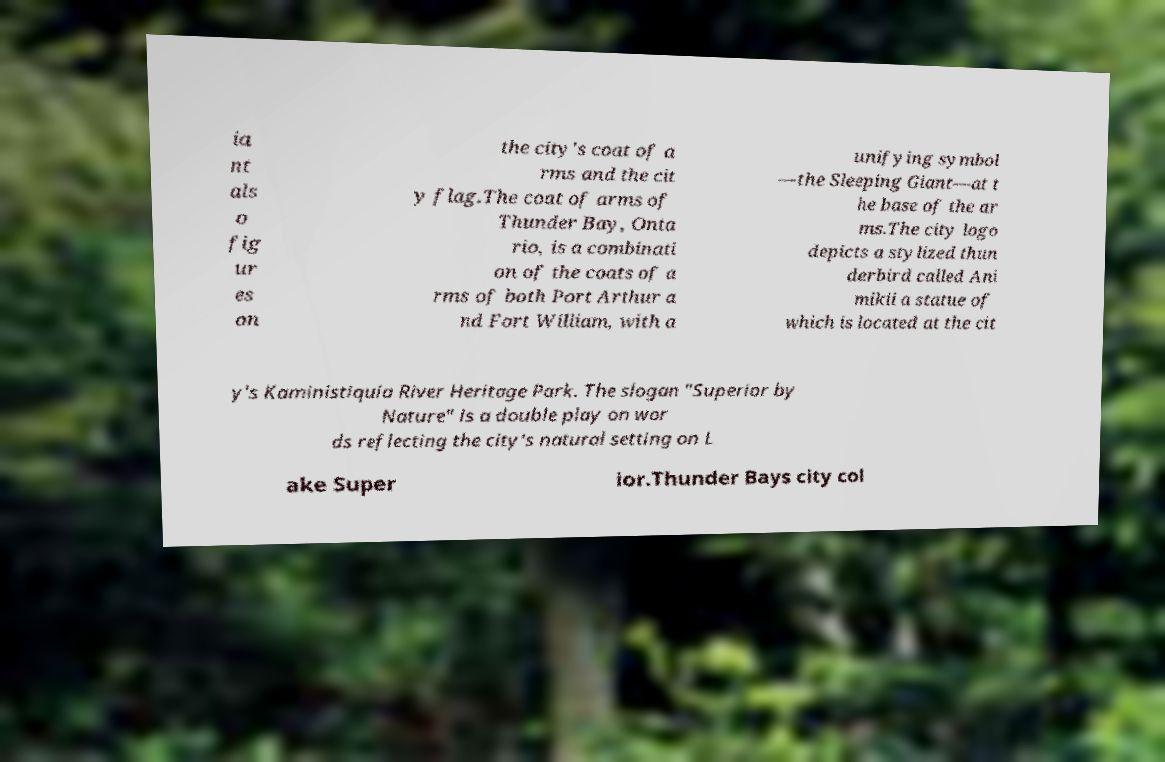What messages or text are displayed in this image? I need them in a readable, typed format. ia nt als o fig ur es on the city's coat of a rms and the cit y flag.The coat of arms of Thunder Bay, Onta rio, is a combinati on of the coats of a rms of both Port Arthur a nd Fort William, with a unifying symbol —the Sleeping Giant—at t he base of the ar ms.The city logo depicts a stylized thun derbird called Ani mikii a statue of which is located at the cit y's Kaministiquia River Heritage Park. The slogan "Superior by Nature" is a double play on wor ds reflecting the city's natural setting on L ake Super ior.Thunder Bays city col 